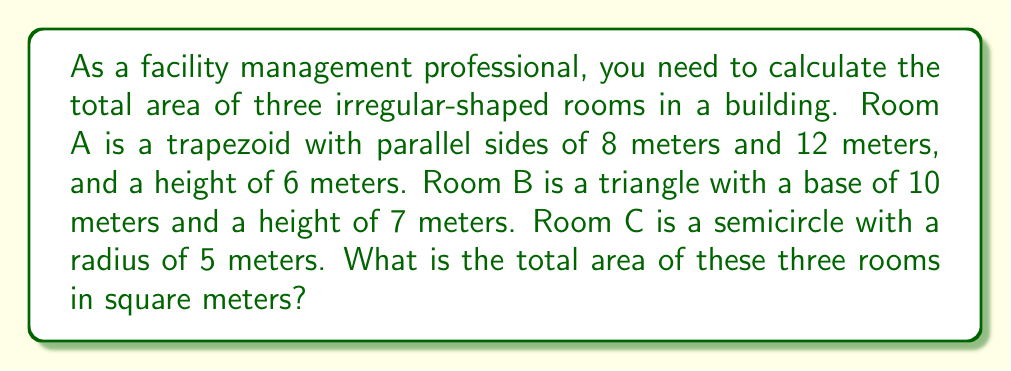Help me with this question. Let's calculate the area of each room separately and then sum them up:

1. Room A (Trapezoid):
   The area of a trapezoid is given by the formula: $A = \frac{1}{2}(a+b)h$
   where $a$ and $b$ are the parallel sides, and $h$ is the height.
   
   $A_A = \frac{1}{2}(8+12) \times 6 = \frac{1}{2} \times 20 \times 6 = 60$ m²

2. Room B (Triangle):
   The area of a triangle is given by the formula: $A = \frac{1}{2}bh$
   where $b$ is the base and $h$ is the height.
   
   $A_B = \frac{1}{2} \times 10 \times 7 = 35$ m²

3. Room C (Semicircle):
   The area of a semicircle is given by the formula: $A = \frac{1}{2}\pi r^2$
   where $r$ is the radius.
   
   $A_C = \frac{1}{2} \times \pi \times 5^2 = \frac{25\pi}{2} \approx 39.27$ m²

Total area:
$$A_{total} = A_A + A_B + A_C = 60 + 35 + \frac{25\pi}{2} \approx 134.27$$ m²
Answer: $134.27$ m² 